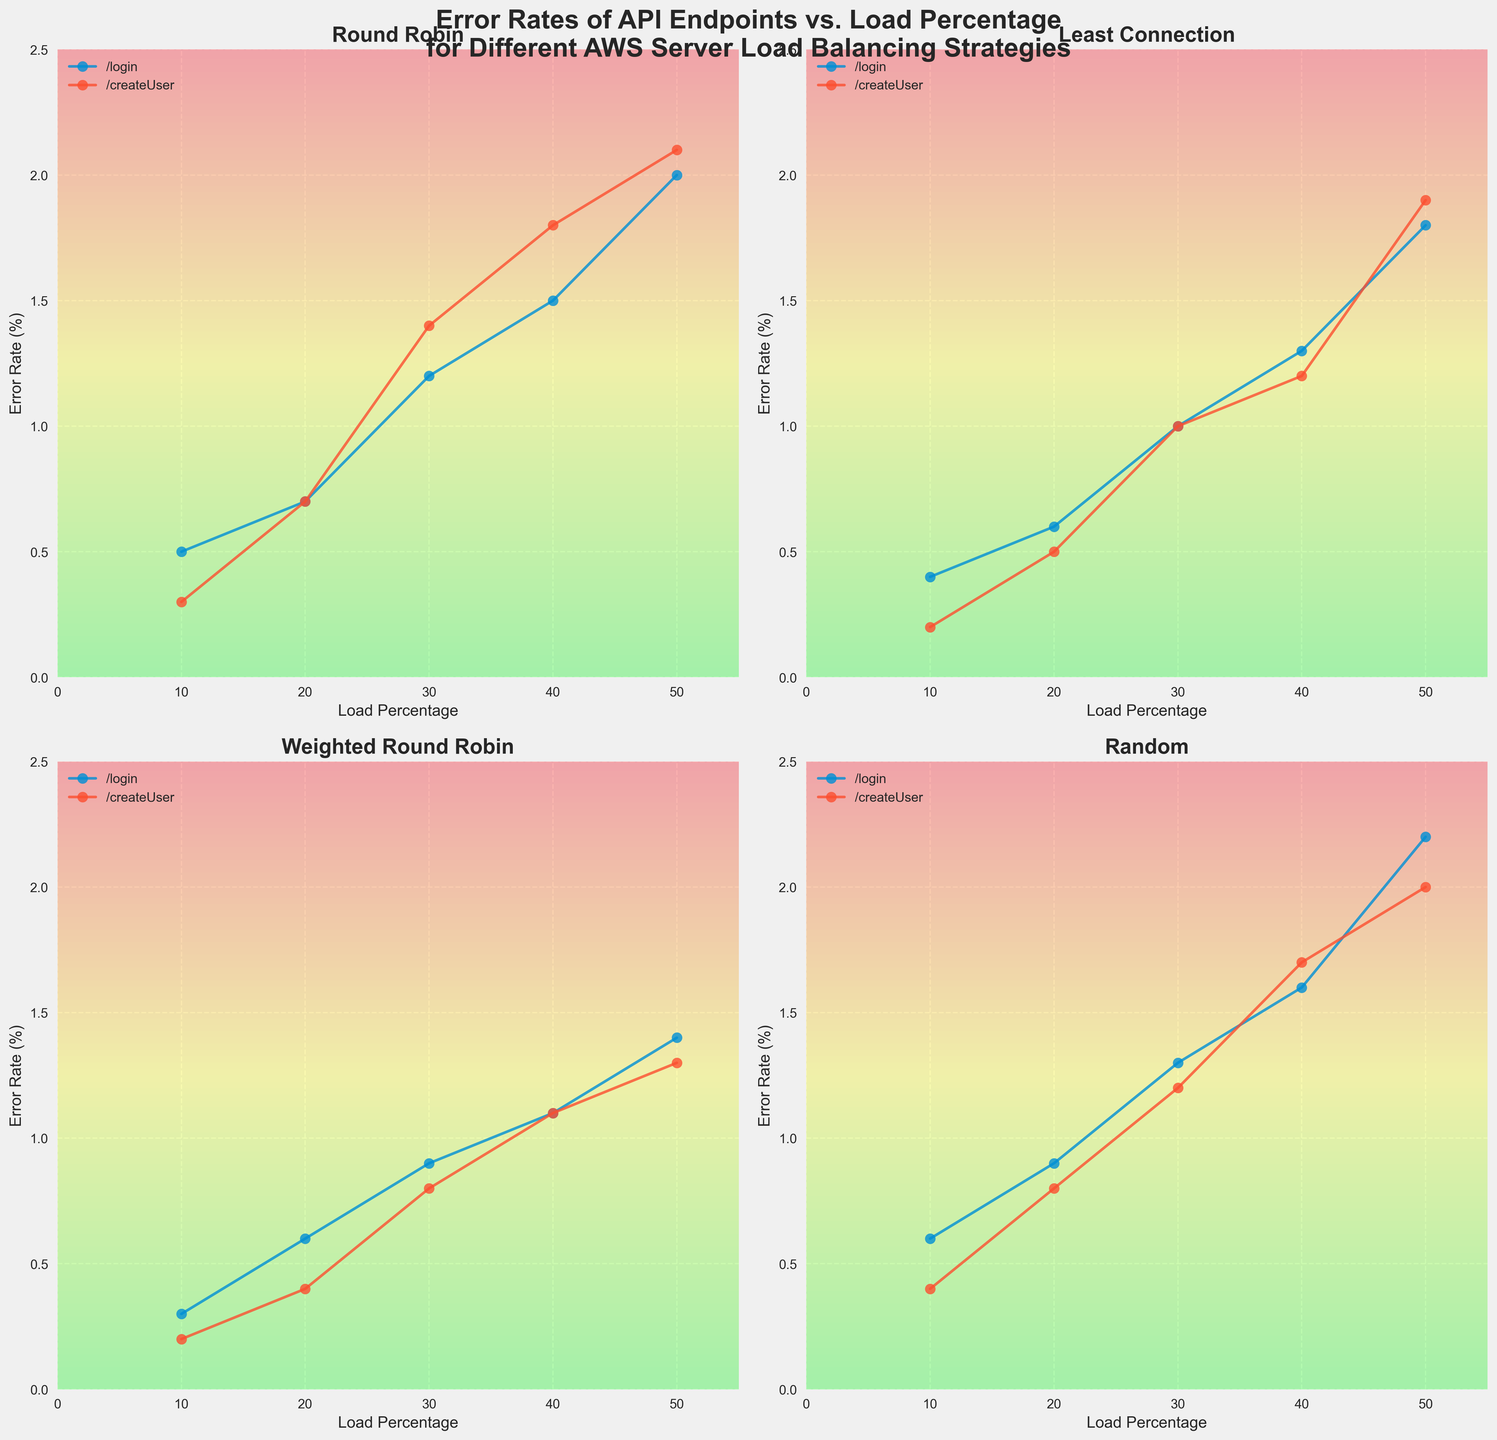What is the title of the figure? The title is prominently displayed at the top of the figure. It reads "Error Rates of API Endpoints vs. Load Percentage for Different AWS Server Load Balancing Strategies".
Answer: Error Rates of API Endpoints vs. Load Percentage for Different AWS Server Load Balancing Strategies Which load balancing strategy has the lowest error rate for the /createUser endpoint at 10% load? By examining the subplots, you can see the error rates for /createUser at 10% load across all strategies. The "Least Connection" strategy has the lowest error rate shown at 0.2%.
Answer: Least Connection What is the error rate for the /login endpoint at 50% load when using the Round Robin strategy? Locate the "Round Robin" subplot and find the data point for 50% load on the /login line. The error rate there is marked at 2.0%.
Answer: 2.0% Compare the error rates for the /login endpoint at 30% load between Weighted Round Robin and Random strategies. Which one is higher? Find the points for 30% load for the /login endpoint in both the Weighted Round Robin and Random strategy subplots. The error rate for Weighted Round Robin is 0.9%, and for Random, it is 1.3%. Random is higher.
Answer: Random What strategy shows an increasing error rate trend for both /login and /createUser endpoints as load percentage increases from 10% to 50%? Check each subplot for consistency in increasing trends from 10% to 50%. All strategies exhibit this trend, judging by the upward-sloping lines.
Answer: All strategies Which endpoint under the Least Connection strategy has a higher error rate at 30% load? Look at the Least Connection subplot and compare the error rates at 30% load. For /login it is 1.0%, and for /createUser it is also 1.0%. They are equal.
Answer: Both are equal Consider the endpoint /createUser. What is the average error rate at 50% load across all strategies? Sum the error rates for /createUser at 50% load from each subplot: 2.1 (Round Robin), 1.9 (Least Connection), 1.3 (Weighted Round Robin), 2.0 (Random). Average = (2.1 + 1.9 + 1.3 + 2.0) / 4 = 1.825%.
Answer: 1.825% In which subplot does the /login endpoint error rate exceed 2.0%? Look through each subplot for the /login endpoint data points. In the "Random" subplot, at 50% load, the error rate exceeds 2.0%.
Answer: Random What is the relationship between load percentage and error rate for the /createUser endpoint in the Weighted Round Robin strategy? Examine the curve for /createUser in the Weighted Round Robin subplot. The error rate increases as the load percentage increases.
Answer: Positive correlation 